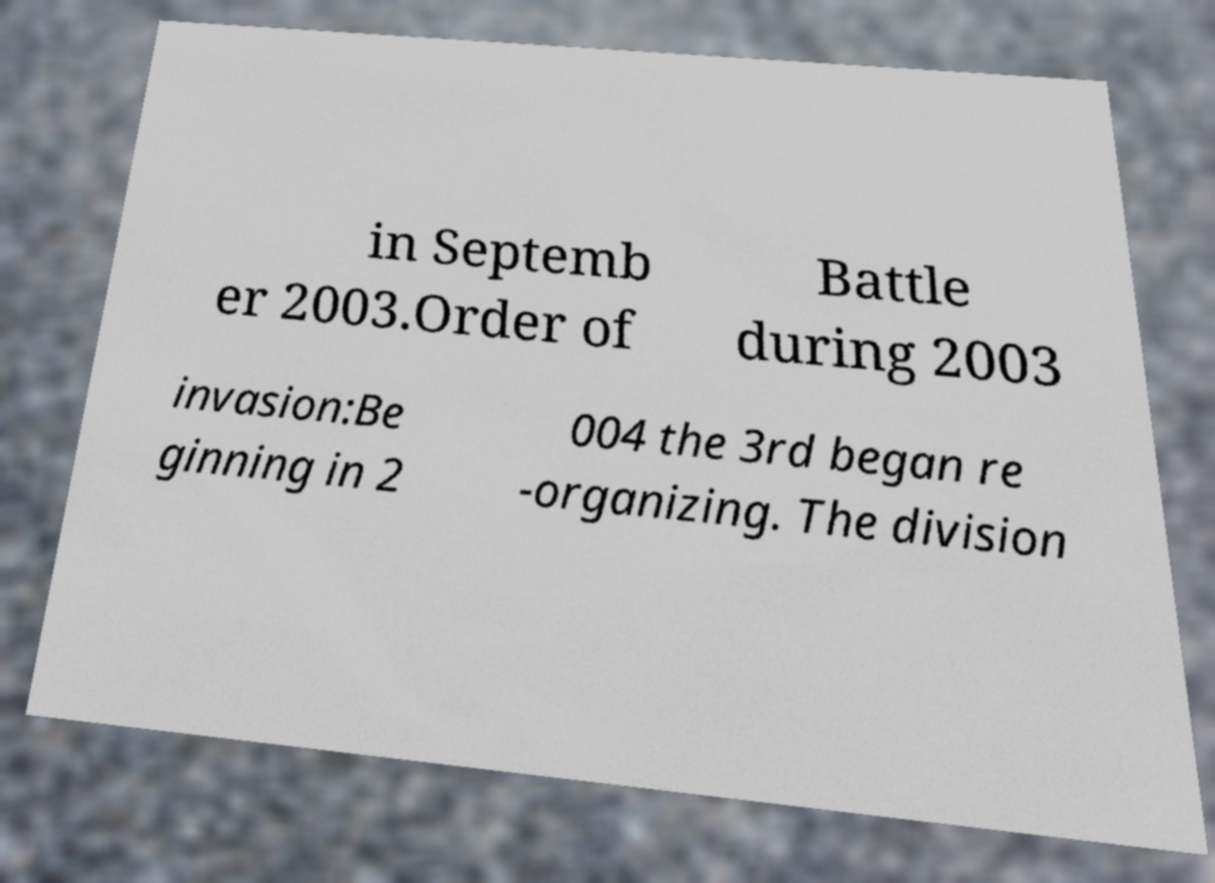What messages or text are displayed in this image? I need them in a readable, typed format. in Septemb er 2003.Order of Battle during 2003 invasion:Be ginning in 2 004 the 3rd began re -organizing. The division 